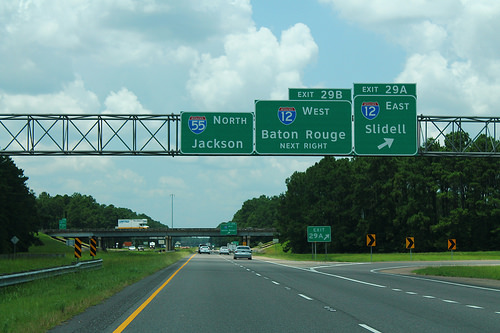<image>
Is there a sign in front of the car? Yes. The sign is positioned in front of the car, appearing closer to the camera viewpoint. 